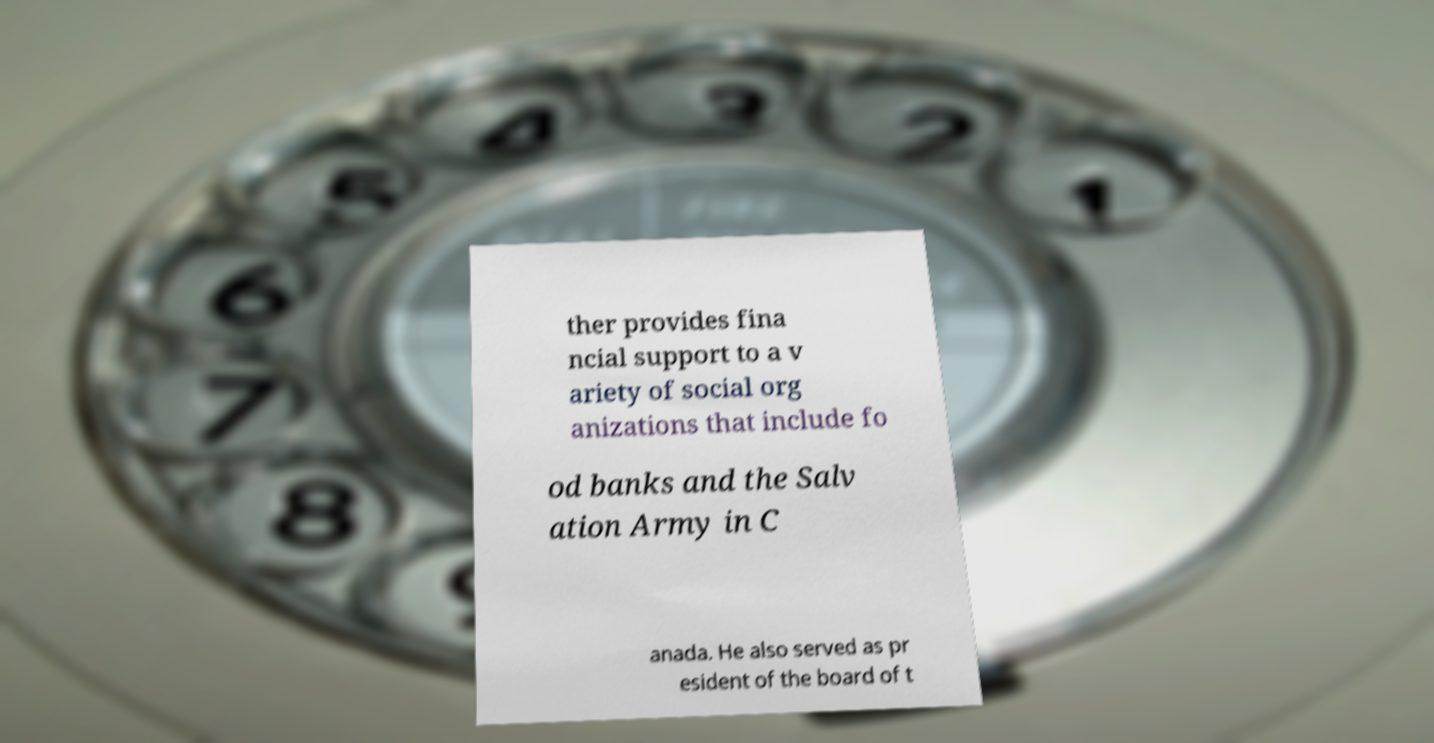Can you read and provide the text displayed in the image?This photo seems to have some interesting text. Can you extract and type it out for me? ther provides fina ncial support to a v ariety of social org anizations that include fo od banks and the Salv ation Army in C anada. He also served as pr esident of the board of t 